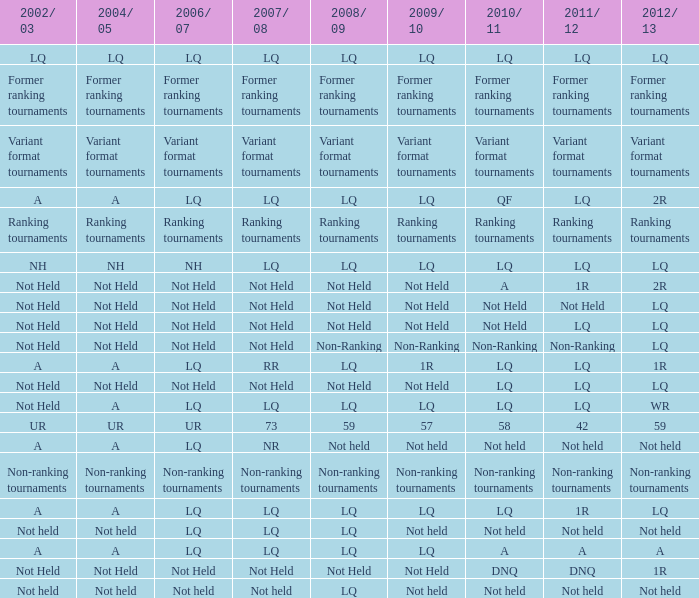Name the 2009/10 with 2011/12 of a LQ. Write the full table. {'header': ['2002/ 03', '2004/ 05', '2006/ 07', '2007/ 08', '2008/ 09', '2009/ 10', '2010/ 11', '2011/ 12', '2012/ 13'], 'rows': [['LQ', 'LQ', 'LQ', 'LQ', 'LQ', 'LQ', 'LQ', 'LQ', 'LQ'], ['Former ranking tournaments', 'Former ranking tournaments', 'Former ranking tournaments', 'Former ranking tournaments', 'Former ranking tournaments', 'Former ranking tournaments', 'Former ranking tournaments', 'Former ranking tournaments', 'Former ranking tournaments'], ['Variant format tournaments', 'Variant format tournaments', 'Variant format tournaments', 'Variant format tournaments', 'Variant format tournaments', 'Variant format tournaments', 'Variant format tournaments', 'Variant format tournaments', 'Variant format tournaments'], ['A', 'A', 'LQ', 'LQ', 'LQ', 'LQ', 'QF', 'LQ', '2R'], ['Ranking tournaments', 'Ranking tournaments', 'Ranking tournaments', 'Ranking tournaments', 'Ranking tournaments', 'Ranking tournaments', 'Ranking tournaments', 'Ranking tournaments', 'Ranking tournaments'], ['NH', 'NH', 'NH', 'LQ', 'LQ', 'LQ', 'LQ', 'LQ', 'LQ'], ['Not Held', 'Not Held', 'Not Held', 'Not Held', 'Not Held', 'Not Held', 'A', '1R', '2R'], ['Not Held', 'Not Held', 'Not Held', 'Not Held', 'Not Held', 'Not Held', 'Not Held', 'Not Held', 'LQ'], ['Not Held', 'Not Held', 'Not Held', 'Not Held', 'Not Held', 'Not Held', 'Not Held', 'LQ', 'LQ'], ['Not Held', 'Not Held', 'Not Held', 'Not Held', 'Non-Ranking', 'Non-Ranking', 'Non-Ranking', 'Non-Ranking', 'LQ'], ['A', 'A', 'LQ', 'RR', 'LQ', '1R', 'LQ', 'LQ', '1R'], ['Not Held', 'Not Held', 'Not Held', 'Not Held', 'Not Held', 'Not Held', 'LQ', 'LQ', 'LQ'], ['Not Held', 'A', 'LQ', 'LQ', 'LQ', 'LQ', 'LQ', 'LQ', 'WR'], ['UR', 'UR', 'UR', '73', '59', '57', '58', '42', '59'], ['A', 'A', 'LQ', 'NR', 'Not held', 'Not held', 'Not held', 'Not held', 'Not held'], ['Non-ranking tournaments', 'Non-ranking tournaments', 'Non-ranking tournaments', 'Non-ranking tournaments', 'Non-ranking tournaments', 'Non-ranking tournaments', 'Non-ranking tournaments', 'Non-ranking tournaments', 'Non-ranking tournaments'], ['A', 'A', 'LQ', 'LQ', 'LQ', 'LQ', 'LQ', '1R', 'LQ'], ['Not held', 'Not held', 'LQ', 'LQ', 'LQ', 'Not held', 'Not held', 'Not held', 'Not held'], ['A', 'A', 'LQ', 'LQ', 'LQ', 'LQ', 'A', 'A', 'A'], ['Not Held', 'Not Held', 'Not Held', 'Not Held', 'Not Held', 'Not Held', 'DNQ', 'DNQ', '1R'], ['Not held', 'Not held', 'Not held', 'Not held', 'LQ', 'Not held', 'Not held', 'Not held', 'Not held']]} 